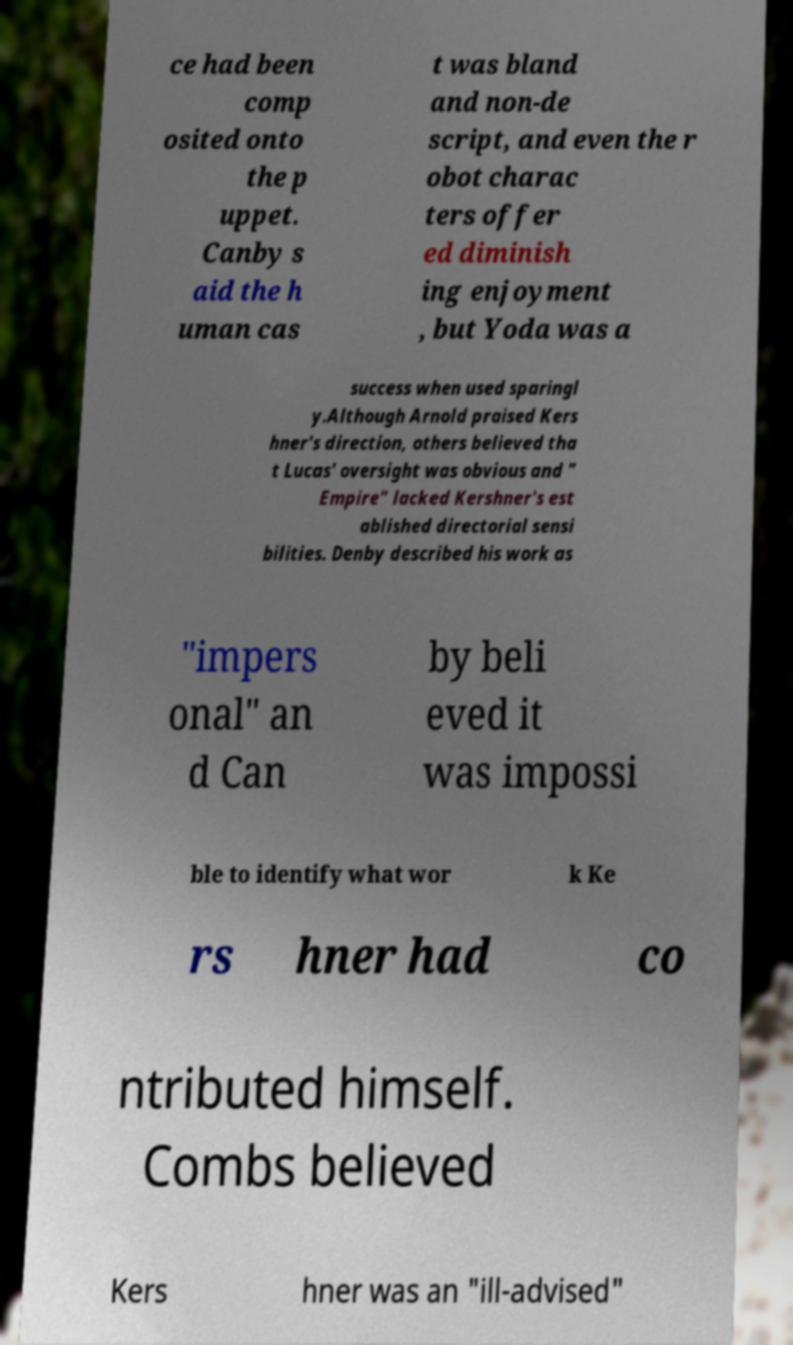For documentation purposes, I need the text within this image transcribed. Could you provide that? ce had been comp osited onto the p uppet. Canby s aid the h uman cas t was bland and non-de script, and even the r obot charac ters offer ed diminish ing enjoyment , but Yoda was a success when used sparingl y.Although Arnold praised Kers hner's direction, others believed tha t Lucas' oversight was obvious and " Empire" lacked Kershner's est ablished directorial sensi bilities. Denby described his work as "impers onal" an d Can by beli eved it was impossi ble to identify what wor k Ke rs hner had co ntributed himself. Combs believed Kers hner was an "ill-advised" 